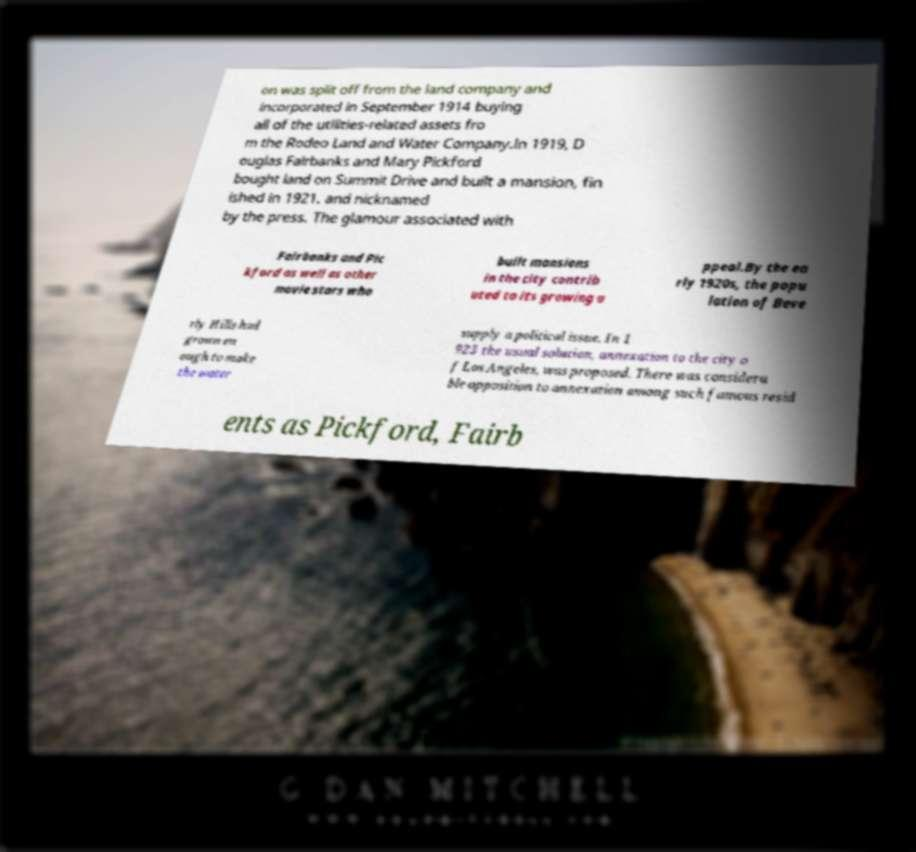Please identify and transcribe the text found in this image. on was split off from the land company and incorporated in September 1914 buying all of the utilities-related assets fro m the Rodeo Land and Water Company.In 1919, D ouglas Fairbanks and Mary Pickford bought land on Summit Drive and built a mansion, fin ished in 1921. and nicknamed by the press. The glamour associated with Fairbanks and Pic kford as well as other movie stars who built mansions in the city contrib uted to its growing a ppeal.By the ea rly 1920s, the popu lation of Beve rly Hills had grown en ough to make the water supply a political issue. In 1 923 the usual solution, annexation to the city o f Los Angeles, was proposed. There was considera ble opposition to annexation among such famous resid ents as Pickford, Fairb 